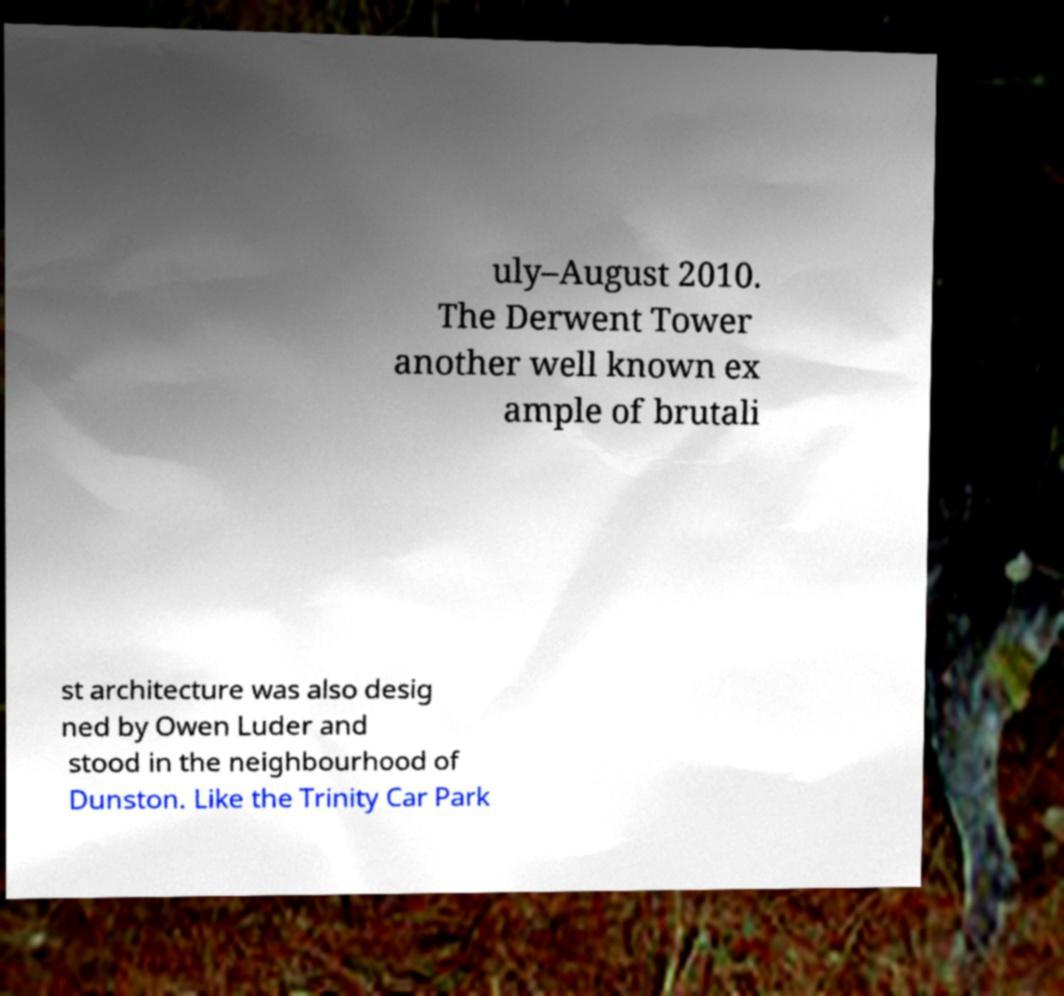Can you read and provide the text displayed in the image?This photo seems to have some interesting text. Can you extract and type it out for me? uly–August 2010. The Derwent Tower another well known ex ample of brutali st architecture was also desig ned by Owen Luder and stood in the neighbourhood of Dunston. Like the Trinity Car Park 